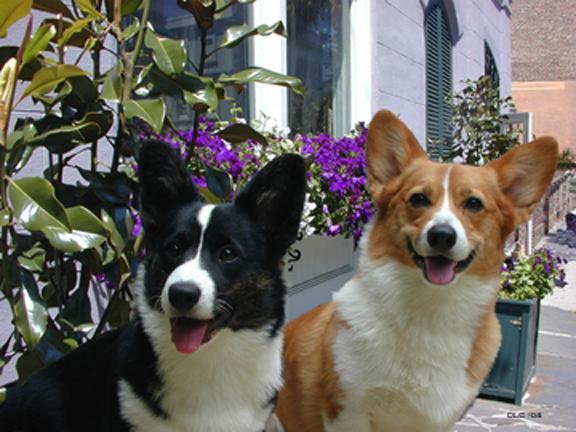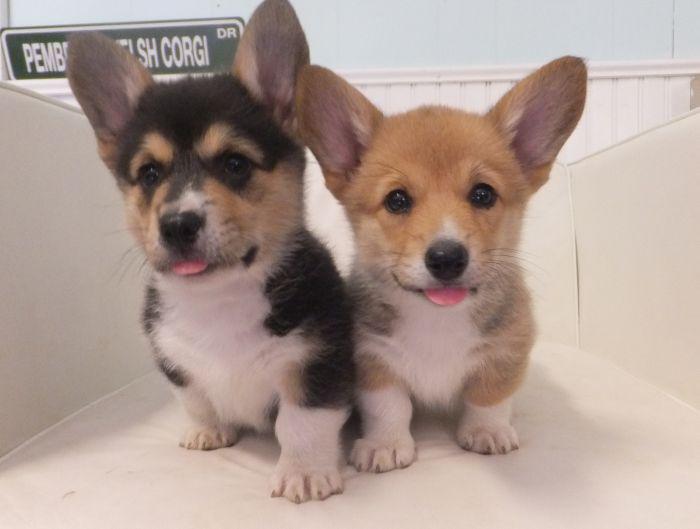The first image is the image on the left, the second image is the image on the right. For the images shown, is this caption "One imag shows a tri-color corgi dog posed side-by-side with an orange-and-white corgi dog, with their bodies turned forward." true? Answer yes or no. Yes. The first image is the image on the left, the second image is the image on the right. Assess this claim about the two images: "There are at most four dogs.". Correct or not? Answer yes or no. Yes. 